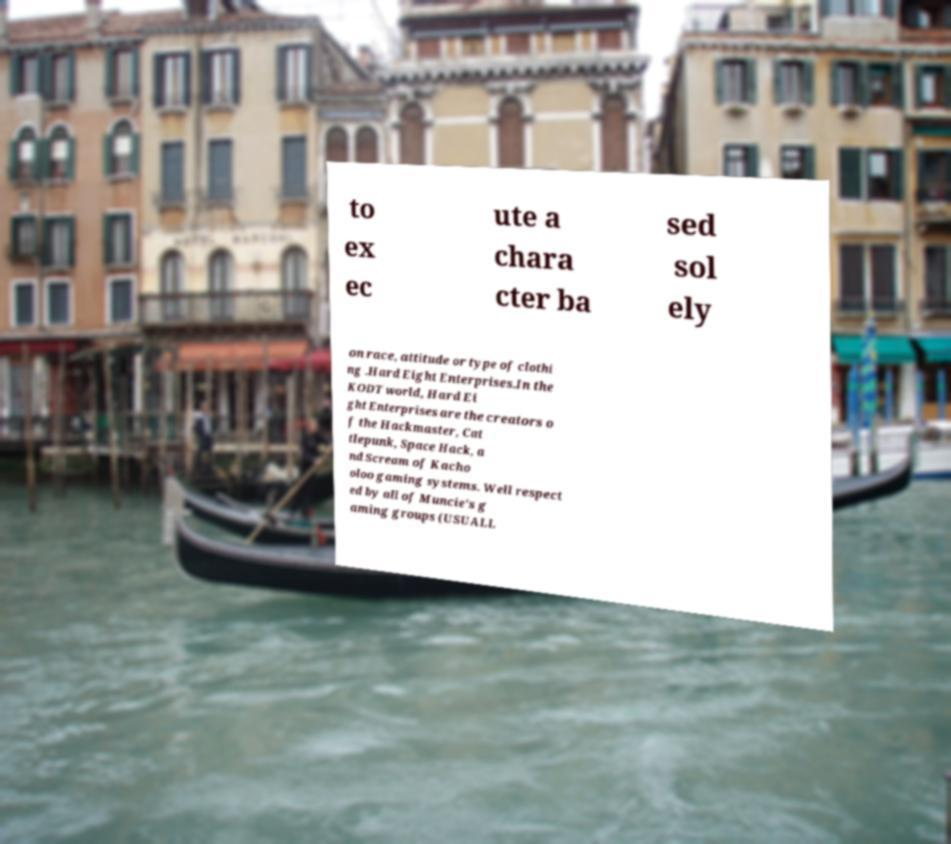Can you accurately transcribe the text from the provided image for me? to ex ec ute a chara cter ba sed sol ely on race, attitude or type of clothi ng .Hard Eight Enterprises.In the KODT world, Hard Ei ght Enterprises are the creators o f the Hackmaster, Cat tlepunk, Space Hack, a nd Scream of Kacho oloo gaming systems. Well respect ed by all of Muncie's g aming groups (USUALL 